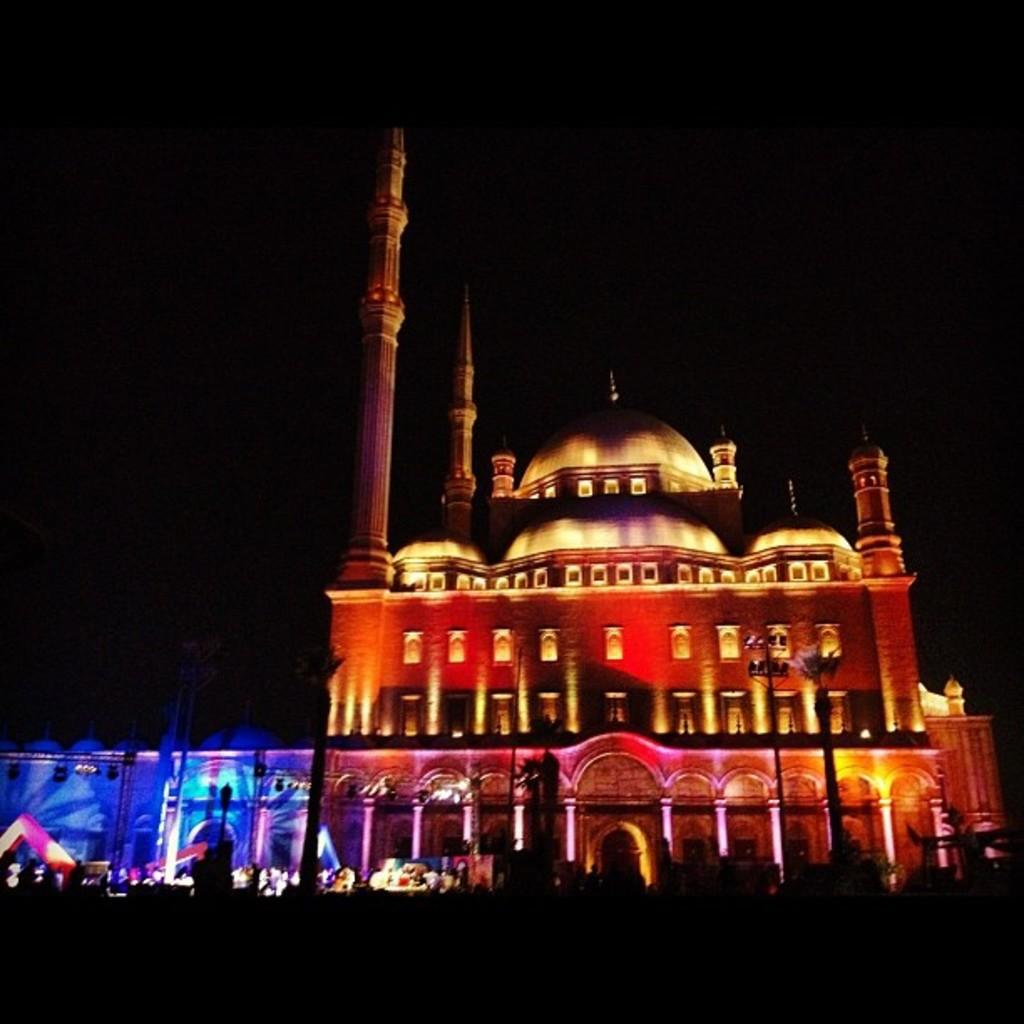What is the main structure in the image? There is a building in the image. What feature of the building is mentioned in the facts? The building has lights. How would you describe the overall appearance of the image? The background of the image is dark. How many clouds can be seen in the image? There are no clouds mentioned or visible in the image. What type of giants are present in the image? There are no giants present in the image. 